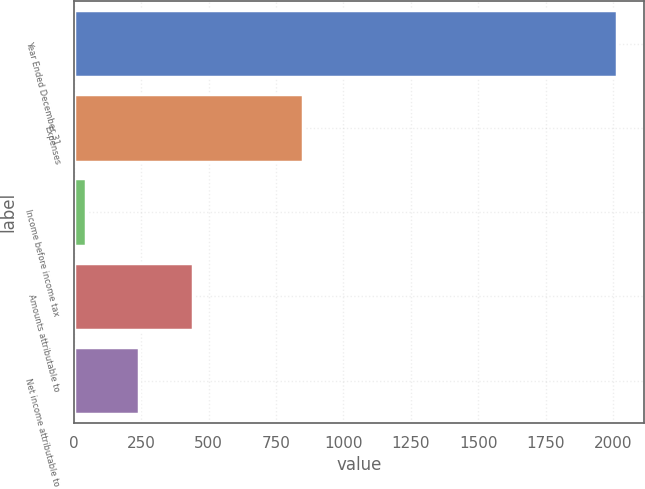<chart> <loc_0><loc_0><loc_500><loc_500><bar_chart><fcel>Year Ended December 31<fcel>Expenses<fcel>Income before income tax<fcel>Amounts attributable to<fcel>Net income attributable to<nl><fcel>2015<fcel>851<fcel>46<fcel>439.8<fcel>242.9<nl></chart> 